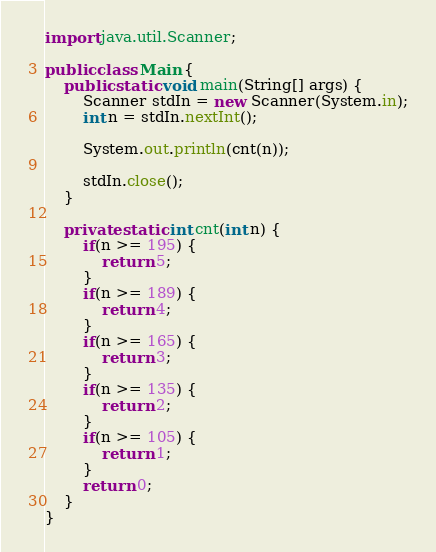<code> <loc_0><loc_0><loc_500><loc_500><_Java_>import java.util.Scanner;

public class Main {
	public static void main(String[] args) {
		Scanner stdIn = new Scanner(System.in);
		int n = stdIn.nextInt();

		System.out.println(cnt(n));

		stdIn.close();
	}

	private static int cnt(int n) {
		if(n >= 195) {
			return 5;
		}
		if(n >= 189) {
			return 4;
		}
		if(n >= 165) {
			return 3;
		}
		if(n >= 135) {
			return 2;
		}
		if(n >= 105) {
			return 1;
		}
		return 0;
	}
}
</code> 